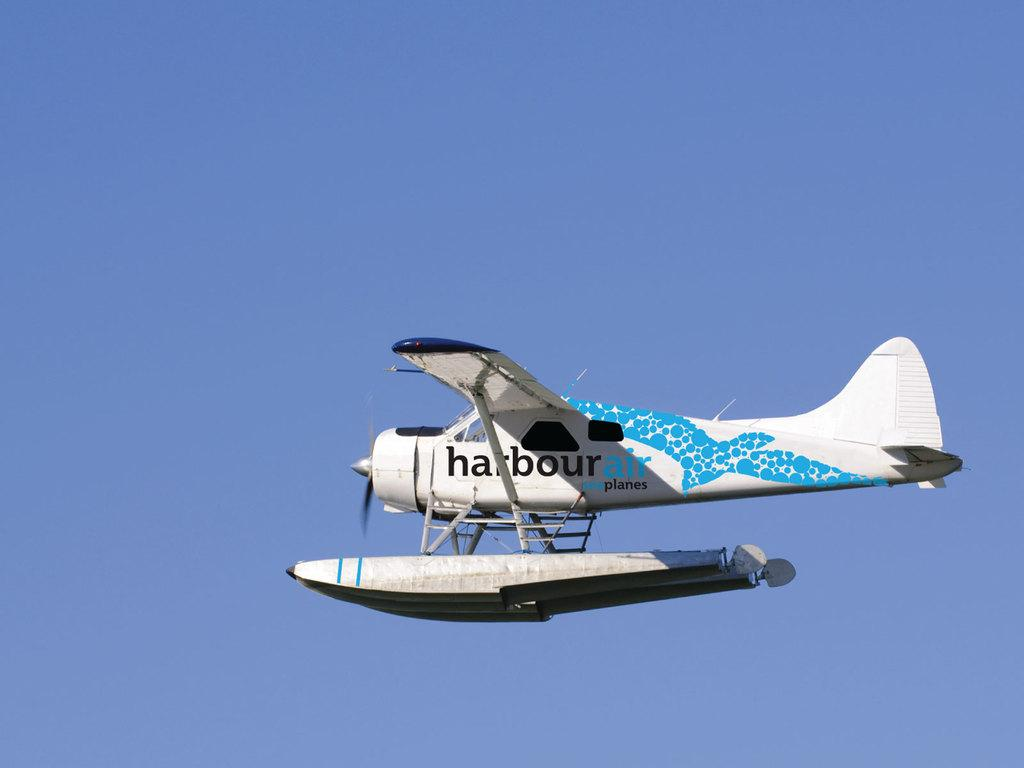What is the main subject of the image? The main subject of the image is an airplane. Where is the airplane located in the image? The airplane is in the sky. What type of children's toys can be seen in the lunchroom in the image? There is no lunchroom or children's toys present in the image; it features an airplane in the sky. 